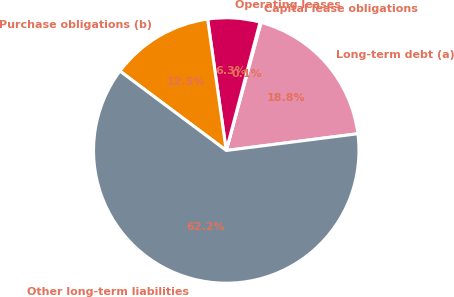Convert chart. <chart><loc_0><loc_0><loc_500><loc_500><pie_chart><fcel>Long-term debt (a)<fcel>Capital lease obligations<fcel>Operating leases<fcel>Purchase obligations (b)<fcel>Other long-term liabilities<nl><fcel>18.76%<fcel>0.13%<fcel>6.34%<fcel>12.55%<fcel>62.23%<nl></chart> 